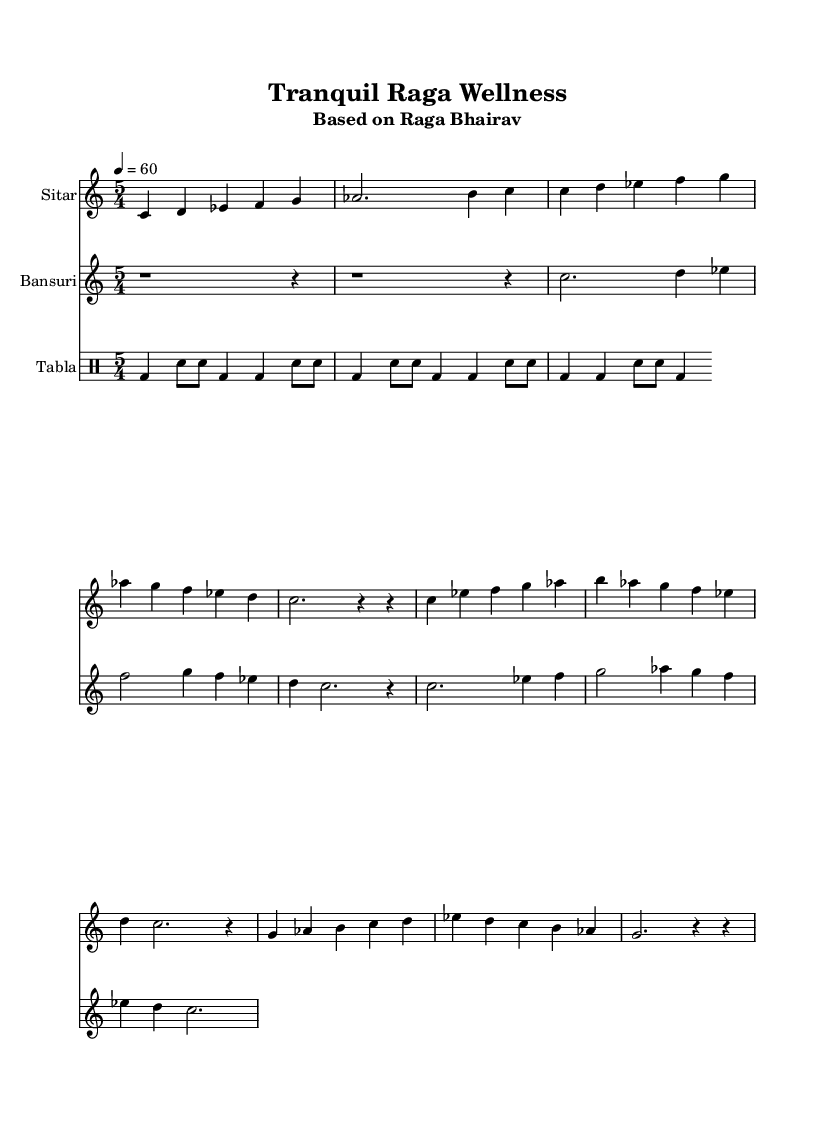What is the key signature of this music? The key signature is C major, as indicated in the global settings of the music sheet. C major has no sharps or flats.
Answer: C major What is the time signature of this music? The time signature is 5/4, which can be found in the global settings and is applicable to all parts of the score.
Answer: 5/4 What is the tempo marking for this piece? The tempo marking is 60 beats per minute, as stated in the global settings at the beginning of the score.
Answer: 60 How many variations of the main phrase are presented in the music? The music includes two variations of the main phrase, which can be identified by the sections labeled as "Variation 1" and "Variation 2" in the sitar part.
Answer: 2 What instruments are featured in this piece? The instruments featured are the sitar, bansuri, and tabla, which are all labeled at the beginning of their respective parts.
Answer: Sitar, Bansuri, Tabla What musical form does the sequence of the music take? The sequence is structured as Alap followed by variations of the main phrase, indicative of the typical flow of Indian classical music.
Answer: Alap and Variations Which raga is this music based on? The piece is based on Raga Bhairav, as indicated in the subtitle of the score. Raga Bhairav is known for its meditative qualities and is often used in spiritual contexts.
Answer: Raga Bhairav 